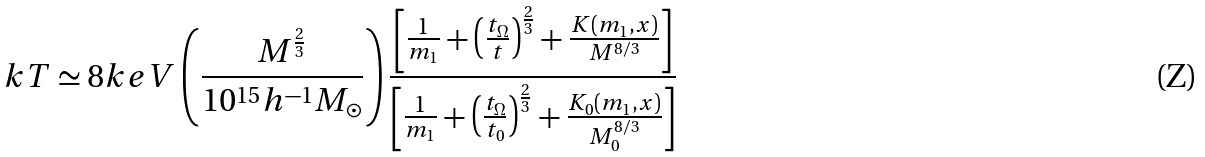Convert formula to latex. <formula><loc_0><loc_0><loc_500><loc_500>k T \simeq 8 k e V \left ( \frac { M ^ { \frac { 2 } { 3 } } } { 1 0 ^ { 1 5 } h ^ { - 1 } M _ { \odot } } \right ) \frac { \left [ \frac { 1 } { m _ { 1 } } + \left ( \frac { t _ { \Omega } } t \right ) ^ { \frac { 2 } { 3 } } + \frac { K ( m _ { 1 } , x ) } { M ^ { 8 / 3 } } \right ] } { \left [ \frac { 1 } { m _ { 1 } } + \left ( \frac { t _ { \Omega } } { t _ { 0 } } \right ) ^ { \frac { 2 } { 3 } } + \frac { K _ { 0 } ( m _ { 1 } , x ) } { M _ { 0 } ^ { 8 / 3 } } \right ] }</formula> 